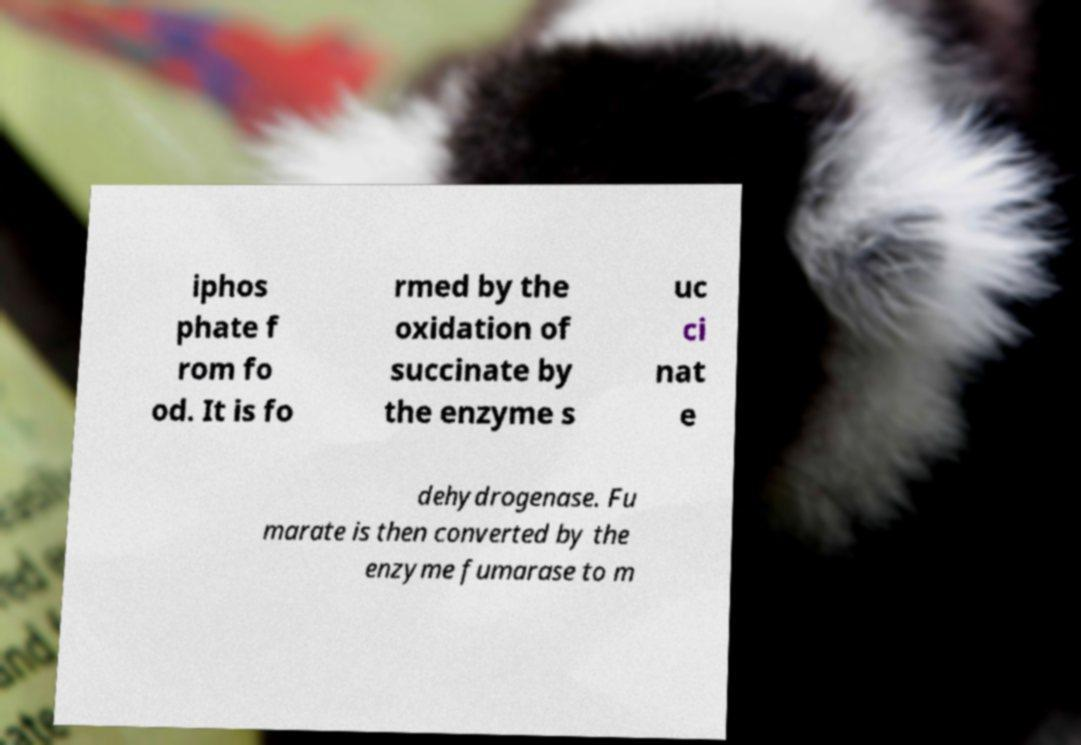There's text embedded in this image that I need extracted. Can you transcribe it verbatim? iphos phate f rom fo od. It is fo rmed by the oxidation of succinate by the enzyme s uc ci nat e dehydrogenase. Fu marate is then converted by the enzyme fumarase to m 